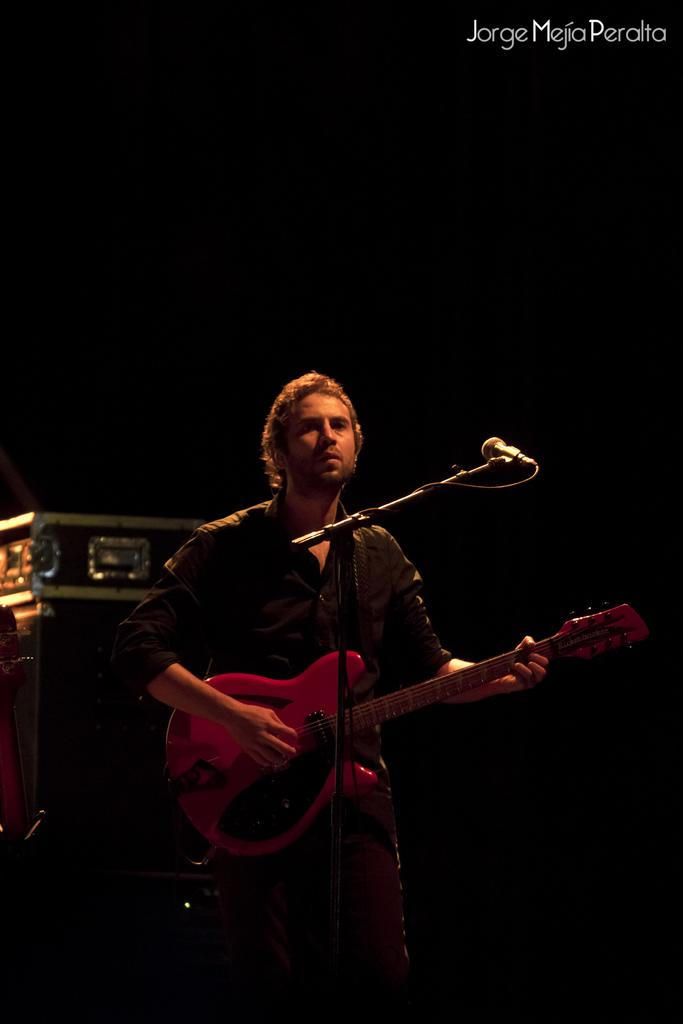Who is the main subject in the image? There is a man in the image. What is the man doing in the image? The man is standing and playing a guitar. What object is in front of the man? There is a microphone in front of the man. What type of doll is the man holding in the image? There is no doll present in the image; the man is playing a guitar and standing near a microphone. 